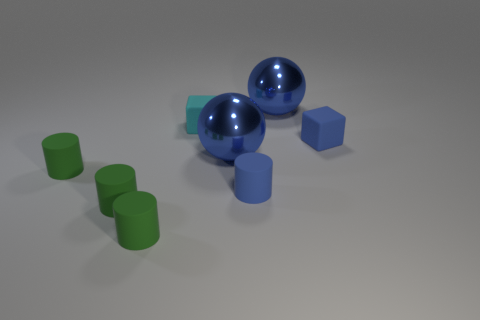The cyan matte block is what size?
Your answer should be very brief. Small. What shape is the tiny blue object that is the same material as the blue block?
Offer a very short reply. Cylinder. Do the blue shiny object in front of the blue block and the cyan rubber object have the same shape?
Give a very brief answer. No. How many objects are tiny brown balls or metallic objects?
Offer a terse response. 2. The tiny thing that is both behind the tiny blue matte cylinder and on the right side of the cyan matte cube is made of what material?
Give a very brief answer. Rubber. Do the cyan matte object and the blue rubber block have the same size?
Provide a short and direct response. Yes. There is a cyan matte thing that is behind the rubber cube that is on the right side of the small cyan rubber thing; what size is it?
Make the answer very short. Small. How many objects are both behind the small blue block and to the left of the small blue cylinder?
Your response must be concise. 1. Are there any tiny rubber objects behind the blue cylinder left of the tiny blue block behind the small blue matte cylinder?
Your answer should be very brief. Yes. There is a blue object that is the same size as the blue rubber cylinder; what shape is it?
Provide a short and direct response. Cube. 